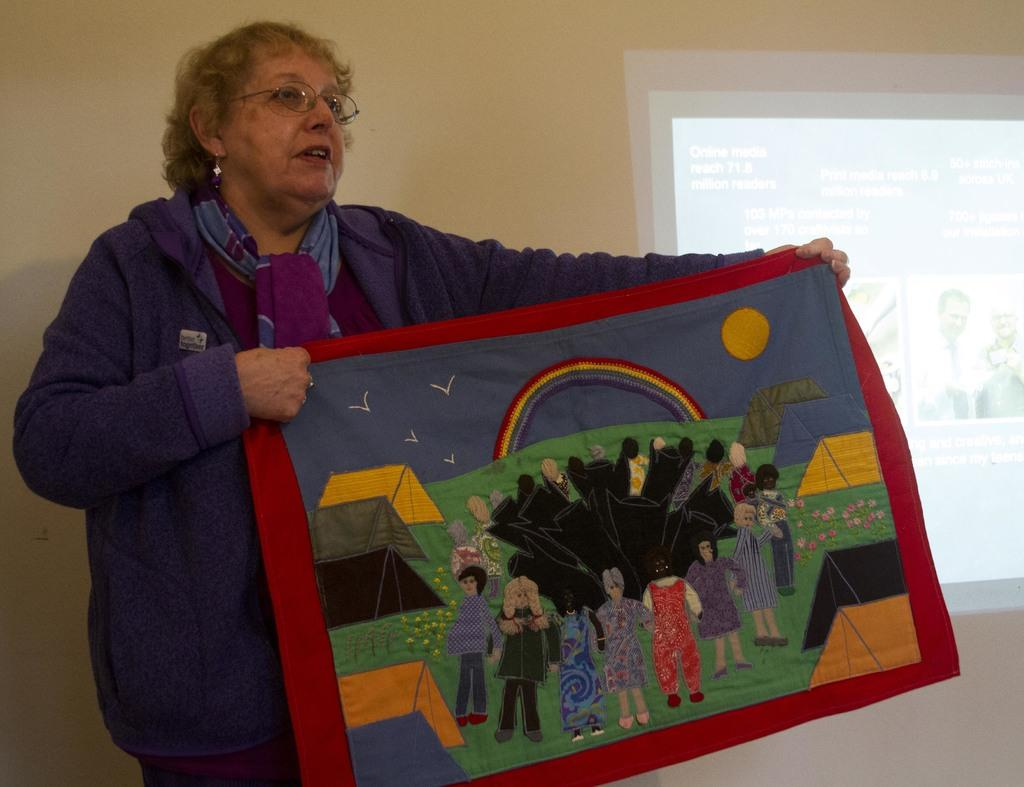What is the person in the image holding? The person is holding a cloth in the image. What can be seen on the cloth? The cloth contains images of people. What can be seen in the background of the image? There is a screen visible in the background of the image. What type of gun is being used to create friction on the cloth in the image? There is no gun present in the image, and the cloth is not being used in a manner that would require friction. 